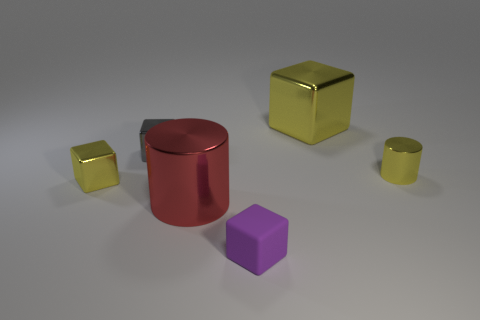Subtract all gray blocks. How many blocks are left? 3 Subtract all cyan spheres. How many yellow blocks are left? 2 Subtract all gray cubes. How many cubes are left? 3 Subtract 1 cylinders. How many cylinders are left? 1 Add 3 big red objects. How many objects exist? 9 Subtract all cylinders. How many objects are left? 4 Subtract all brown cylinders. Subtract all purple blocks. How many cylinders are left? 2 Add 6 red metallic cylinders. How many red metallic cylinders exist? 7 Subtract 1 purple cubes. How many objects are left? 5 Subtract all small cyan objects. Subtract all small gray cubes. How many objects are left? 5 